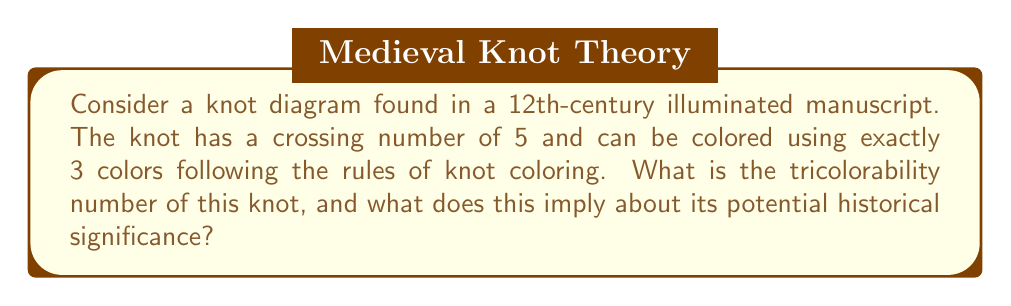Can you answer this question? To solve this problem, we need to understand the concept of tricolorability and its implications for knot theory and historical analysis:

1. Tricolorability:
   A knot is tricolorable if its strands can be colored using three colors such that at each crossing, either all three colors are present or only one color is used.

2. Tricolorability number:
   The tricolorability number is defined as the number of distinct valid colorings of a knot, including the trivial all-one-color coloring.

3. Calculation:
   For a knot with $n$ crossings, the maximum number of distinct colorings is $3^n$.
   In this case, with 5 crossings, the maximum would be $3^5 = 243$.
   However, we're told the knot can be colored using exactly 3 colors.

4. Tricolorability number for this knot:
   The trivial coloring (all one color) always exists.
   We're told there's at least one non-trivial coloring using 3 colors.
   Therefore, the tricolorability number is 3.

5. Historical significance:
   The tricolorability of a knot provides information about its complexity and structure.
   A tricolorable knot (tricolorability number > 1) implies the knot is non-trivial.
   This suggests that the knot in the manuscript represents a deliberate, complex design rather than a simple decorative element.

6. Computational approach:
   For a Ph.D. candidate in history using computational techniques:
   - Develop an algorithm to analyze knot diagrams in historical manuscripts.
   - Use image processing to extract knot structures.
   - Implement a tricolorability checker to assess knot complexity across various manuscripts.
   - Compare results to track the evolution of knot complexity in historical documents over time.

This approach combines traditional historical analysis with modern computational methods, potentially revealing new insights into the development of mathematical concepts and artistic techniques in medieval manuscripts.
Answer: Tricolorability number: 3. Implies non-trivial, deliberately complex knot design. 